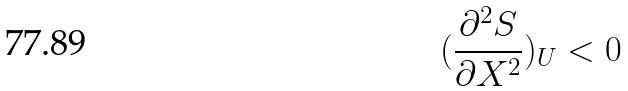<formula> <loc_0><loc_0><loc_500><loc_500>( \frac { \partial ^ { 2 } S } { \partial X ^ { 2 } } ) _ { U } < 0</formula> 